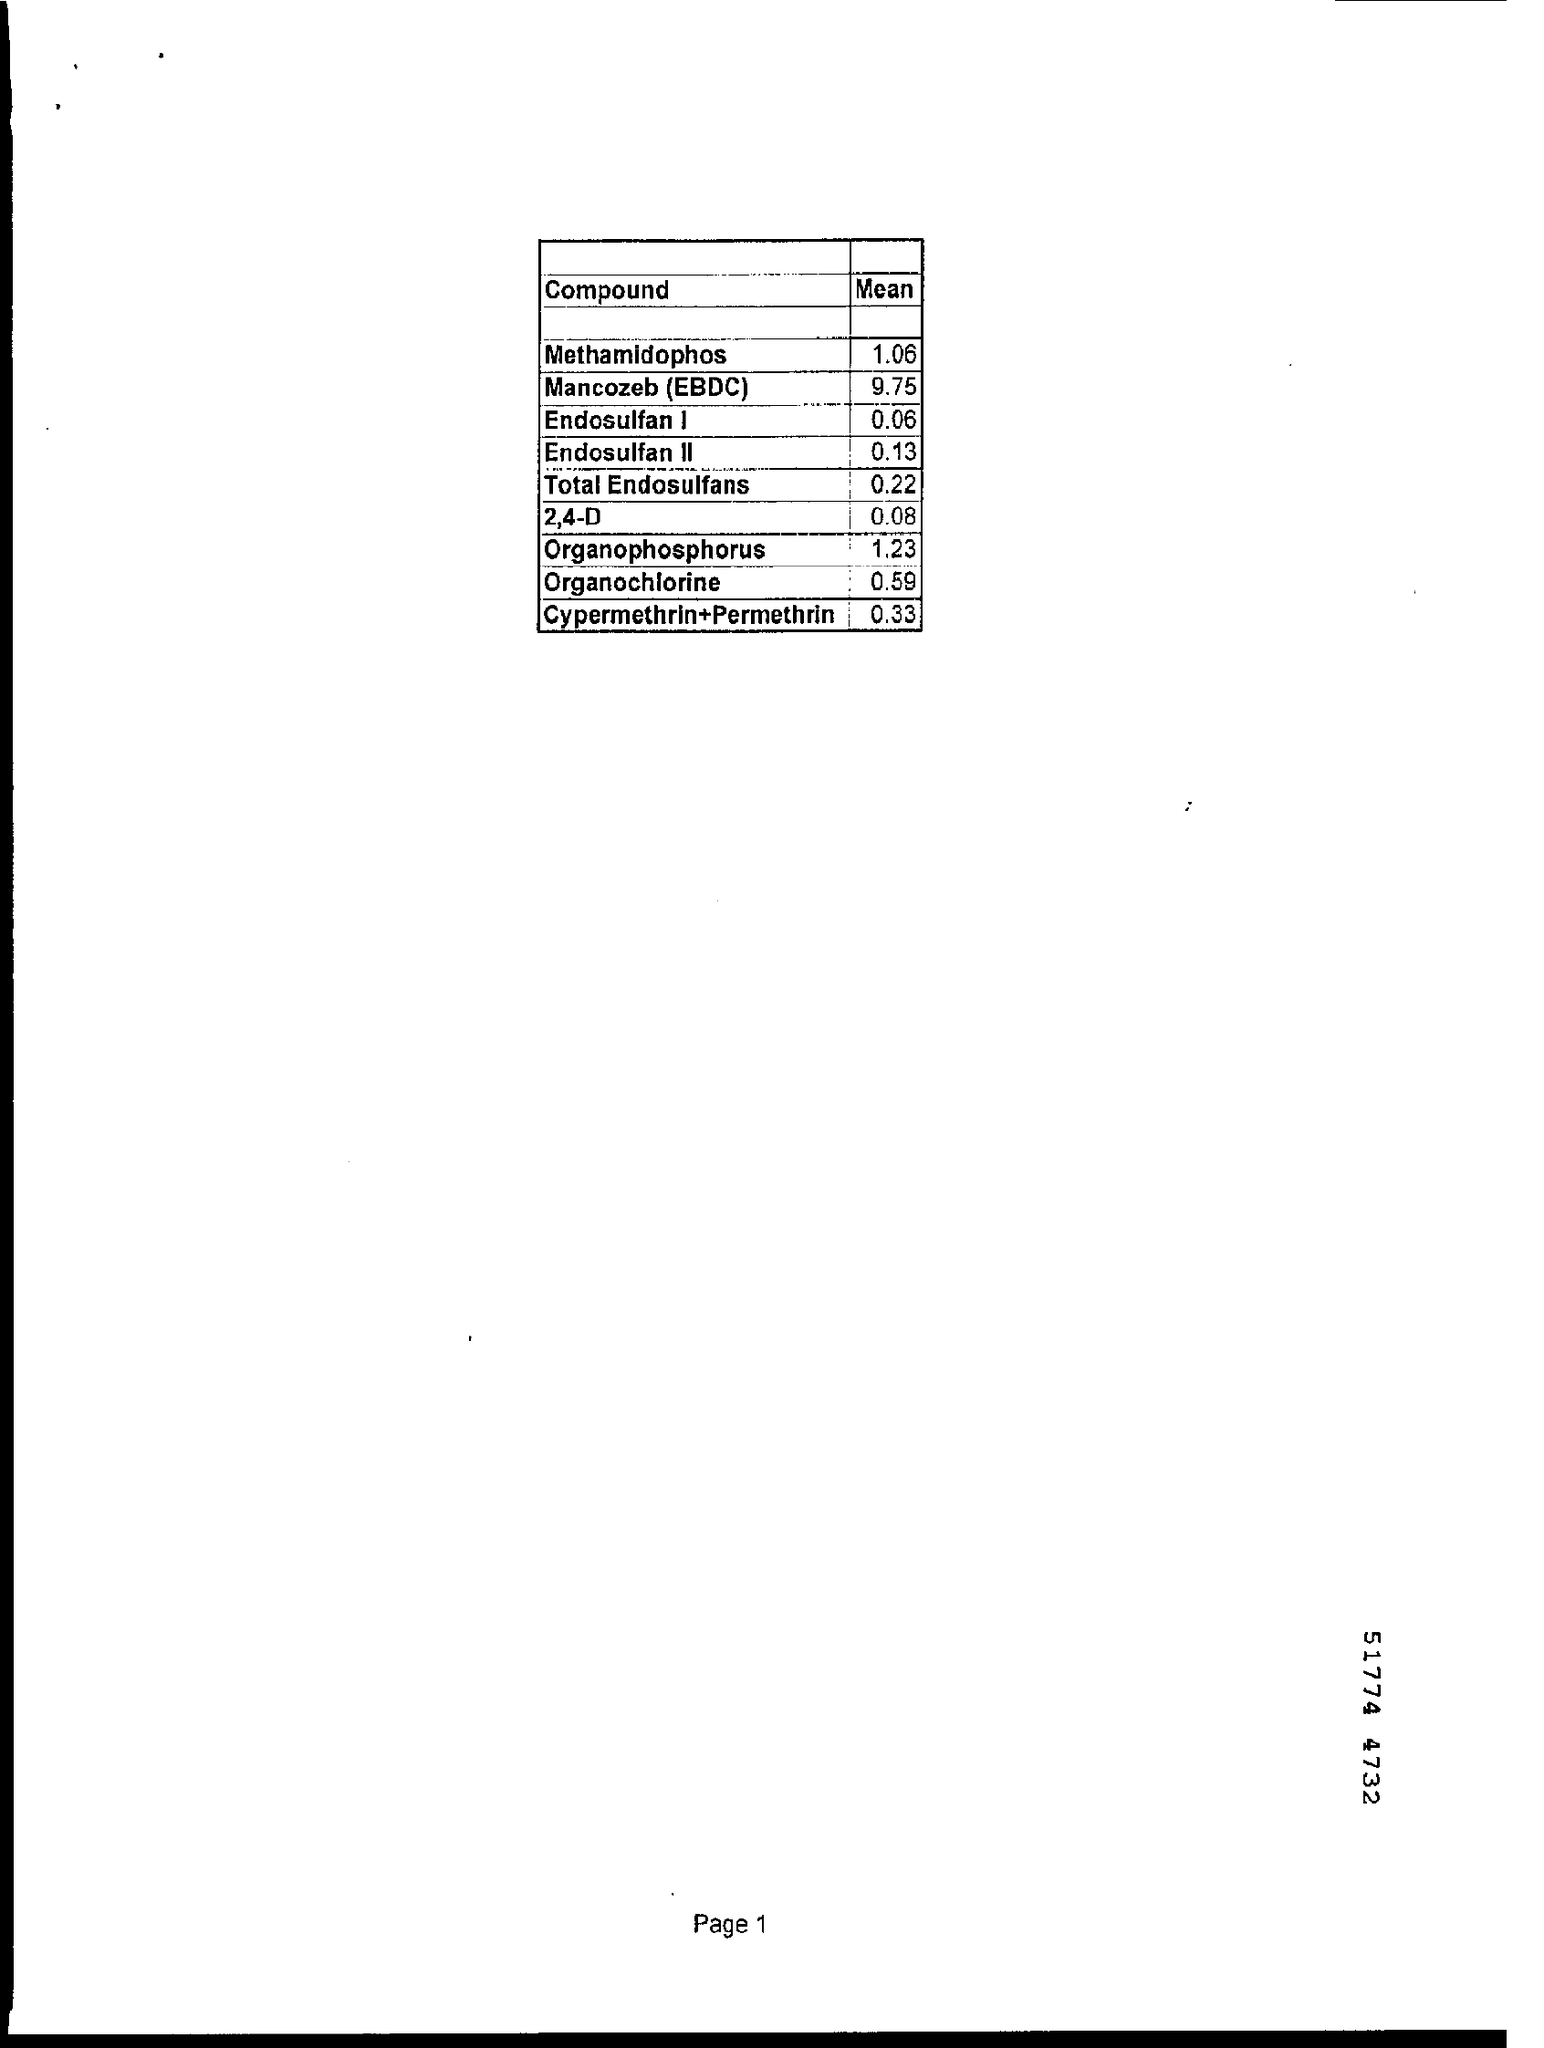Name the compound with 1.23 Mean?
Offer a terse response. Organophosphorus. What is the Mean of 2,4-D?
Keep it short and to the point. 0.08. 